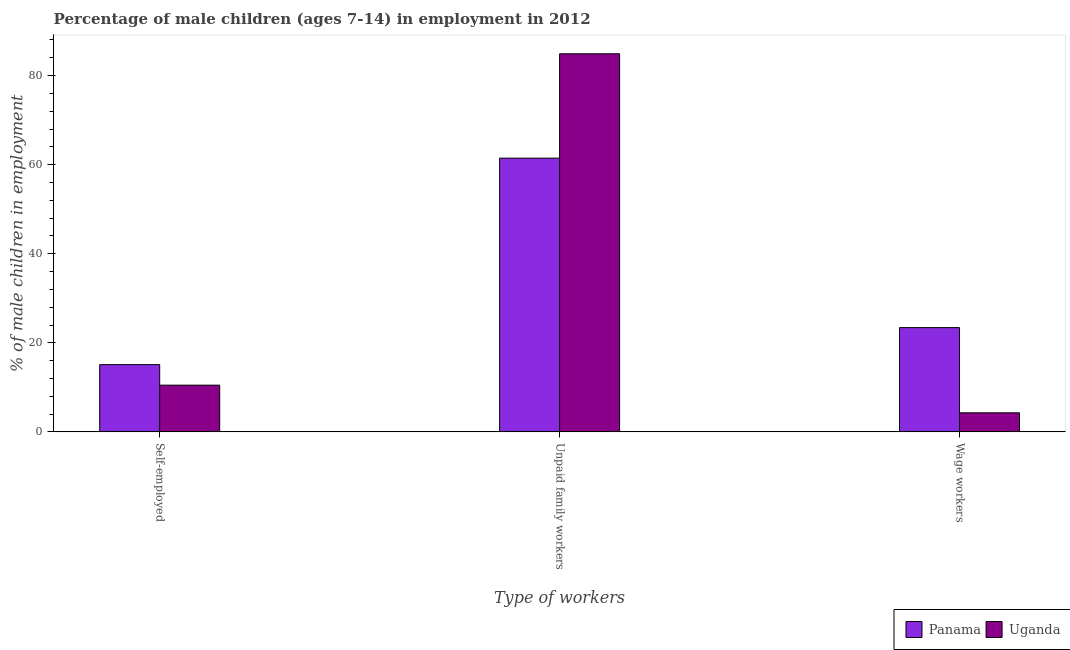How many different coloured bars are there?
Provide a succinct answer. 2. How many groups of bars are there?
Your answer should be very brief. 3. Are the number of bars per tick equal to the number of legend labels?
Offer a terse response. Yes. How many bars are there on the 3rd tick from the left?
Ensure brevity in your answer.  2. How many bars are there on the 2nd tick from the right?
Your response must be concise. 2. What is the label of the 2nd group of bars from the left?
Your answer should be very brief. Unpaid family workers. What is the percentage of children employed as wage workers in Panama?
Provide a short and direct response. 23.42. Across all countries, what is the maximum percentage of children employed as unpaid family workers?
Make the answer very short. 84.9. Across all countries, what is the minimum percentage of children employed as unpaid family workers?
Ensure brevity in your answer.  61.47. In which country was the percentage of children employed as unpaid family workers maximum?
Give a very brief answer. Uganda. In which country was the percentage of children employed as wage workers minimum?
Offer a very short reply. Uganda. What is the total percentage of children employed as unpaid family workers in the graph?
Give a very brief answer. 146.37. What is the difference between the percentage of children employed as wage workers in Panama and that in Uganda?
Ensure brevity in your answer.  19.13. What is the difference between the percentage of children employed as unpaid family workers in Panama and the percentage of children employed as wage workers in Uganda?
Offer a terse response. 57.18. What is the average percentage of self employed children per country?
Make the answer very short. 12.8. What is the difference between the percentage of children employed as unpaid family workers and percentage of children employed as wage workers in Panama?
Your answer should be compact. 38.05. In how many countries, is the percentage of children employed as unpaid family workers greater than 4 %?
Provide a succinct answer. 2. What is the ratio of the percentage of children employed as unpaid family workers in Panama to that in Uganda?
Your response must be concise. 0.72. Is the percentage of children employed as unpaid family workers in Panama less than that in Uganda?
Your answer should be very brief. Yes. Is the difference between the percentage of self employed children in Panama and Uganda greater than the difference between the percentage of children employed as unpaid family workers in Panama and Uganda?
Offer a terse response. Yes. What is the difference between the highest and the second highest percentage of children employed as wage workers?
Offer a terse response. 19.13. What is the difference between the highest and the lowest percentage of children employed as unpaid family workers?
Your answer should be very brief. 23.43. Is the sum of the percentage of children employed as unpaid family workers in Uganda and Panama greater than the maximum percentage of self employed children across all countries?
Provide a succinct answer. Yes. What does the 2nd bar from the left in Unpaid family workers represents?
Keep it short and to the point. Uganda. What does the 2nd bar from the right in Self-employed represents?
Provide a succinct answer. Panama. How many bars are there?
Provide a short and direct response. 6. How many countries are there in the graph?
Keep it short and to the point. 2. What is the difference between two consecutive major ticks on the Y-axis?
Your answer should be very brief. 20. Are the values on the major ticks of Y-axis written in scientific E-notation?
Ensure brevity in your answer.  No. Does the graph contain any zero values?
Your answer should be compact. No. Does the graph contain grids?
Provide a short and direct response. No. How many legend labels are there?
Your answer should be compact. 2. How are the legend labels stacked?
Your answer should be very brief. Horizontal. What is the title of the graph?
Offer a terse response. Percentage of male children (ages 7-14) in employment in 2012. What is the label or title of the X-axis?
Offer a very short reply. Type of workers. What is the label or title of the Y-axis?
Ensure brevity in your answer.  % of male children in employment. What is the % of male children in employment in Panama in Self-employed?
Provide a succinct answer. 15.11. What is the % of male children in employment of Uganda in Self-employed?
Make the answer very short. 10.5. What is the % of male children in employment of Panama in Unpaid family workers?
Your response must be concise. 61.47. What is the % of male children in employment of Uganda in Unpaid family workers?
Make the answer very short. 84.9. What is the % of male children in employment in Panama in Wage workers?
Your response must be concise. 23.42. What is the % of male children in employment of Uganda in Wage workers?
Your response must be concise. 4.29. Across all Type of workers, what is the maximum % of male children in employment in Panama?
Offer a very short reply. 61.47. Across all Type of workers, what is the maximum % of male children in employment of Uganda?
Give a very brief answer. 84.9. Across all Type of workers, what is the minimum % of male children in employment of Panama?
Offer a very short reply. 15.11. Across all Type of workers, what is the minimum % of male children in employment of Uganda?
Offer a very short reply. 4.29. What is the total % of male children in employment in Panama in the graph?
Your answer should be compact. 100. What is the total % of male children in employment in Uganda in the graph?
Keep it short and to the point. 99.69. What is the difference between the % of male children in employment in Panama in Self-employed and that in Unpaid family workers?
Offer a very short reply. -46.36. What is the difference between the % of male children in employment of Uganda in Self-employed and that in Unpaid family workers?
Give a very brief answer. -74.4. What is the difference between the % of male children in employment in Panama in Self-employed and that in Wage workers?
Provide a short and direct response. -8.31. What is the difference between the % of male children in employment in Uganda in Self-employed and that in Wage workers?
Your answer should be very brief. 6.21. What is the difference between the % of male children in employment of Panama in Unpaid family workers and that in Wage workers?
Provide a short and direct response. 38.05. What is the difference between the % of male children in employment in Uganda in Unpaid family workers and that in Wage workers?
Keep it short and to the point. 80.61. What is the difference between the % of male children in employment of Panama in Self-employed and the % of male children in employment of Uganda in Unpaid family workers?
Provide a short and direct response. -69.79. What is the difference between the % of male children in employment of Panama in Self-employed and the % of male children in employment of Uganda in Wage workers?
Your answer should be compact. 10.82. What is the difference between the % of male children in employment in Panama in Unpaid family workers and the % of male children in employment in Uganda in Wage workers?
Keep it short and to the point. 57.18. What is the average % of male children in employment in Panama per Type of workers?
Provide a short and direct response. 33.33. What is the average % of male children in employment in Uganda per Type of workers?
Offer a terse response. 33.23. What is the difference between the % of male children in employment of Panama and % of male children in employment of Uganda in Self-employed?
Ensure brevity in your answer.  4.61. What is the difference between the % of male children in employment in Panama and % of male children in employment in Uganda in Unpaid family workers?
Make the answer very short. -23.43. What is the difference between the % of male children in employment in Panama and % of male children in employment in Uganda in Wage workers?
Your answer should be very brief. 19.13. What is the ratio of the % of male children in employment in Panama in Self-employed to that in Unpaid family workers?
Your response must be concise. 0.25. What is the ratio of the % of male children in employment of Uganda in Self-employed to that in Unpaid family workers?
Provide a succinct answer. 0.12. What is the ratio of the % of male children in employment of Panama in Self-employed to that in Wage workers?
Ensure brevity in your answer.  0.65. What is the ratio of the % of male children in employment of Uganda in Self-employed to that in Wage workers?
Keep it short and to the point. 2.45. What is the ratio of the % of male children in employment of Panama in Unpaid family workers to that in Wage workers?
Offer a very short reply. 2.62. What is the ratio of the % of male children in employment in Uganda in Unpaid family workers to that in Wage workers?
Provide a succinct answer. 19.79. What is the difference between the highest and the second highest % of male children in employment in Panama?
Ensure brevity in your answer.  38.05. What is the difference between the highest and the second highest % of male children in employment of Uganda?
Ensure brevity in your answer.  74.4. What is the difference between the highest and the lowest % of male children in employment in Panama?
Your answer should be very brief. 46.36. What is the difference between the highest and the lowest % of male children in employment in Uganda?
Make the answer very short. 80.61. 